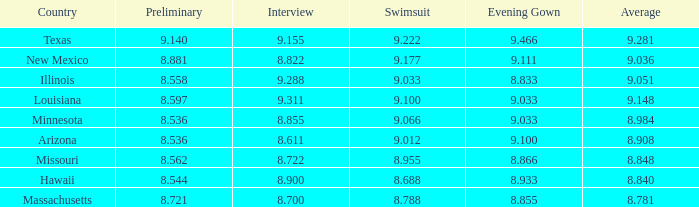What country had a swimsuit score of 8.788? Massachusetts. 